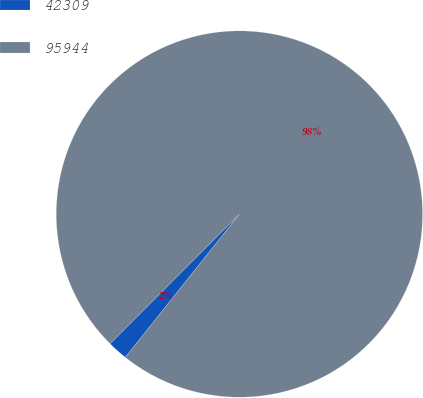<chart> <loc_0><loc_0><loc_500><loc_500><pie_chart><fcel>42309<fcel>95944<nl><fcel>1.78%<fcel>98.22%<nl></chart> 